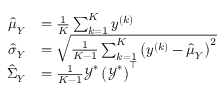<formula> <loc_0><loc_0><loc_500><loc_500>\begin{array} { r l } { \hat { \mu } _ { Y } } & { = \frac { 1 } { K } \sum _ { k = 1 } ^ { K } y ^ { \left ( k \right ) } } \\ { \hat { \sigma } _ { Y } } & { = \sqrt { \frac { 1 } { K - 1 } \sum _ { k = 1 } ^ { K } \left ( y ^ { \left ( k \right ) } - \hat { \mu } _ { Y } \right ) ^ { 2 } } } \\ { \hat { \Sigma } _ { Y } } & { = \frac { 1 } { K - 1 } \mathcal { Y } ^ { \ast } \left ( \mathcal { Y } ^ { \ast } \right ) ^ { \intercal } } \end{array}</formula> 